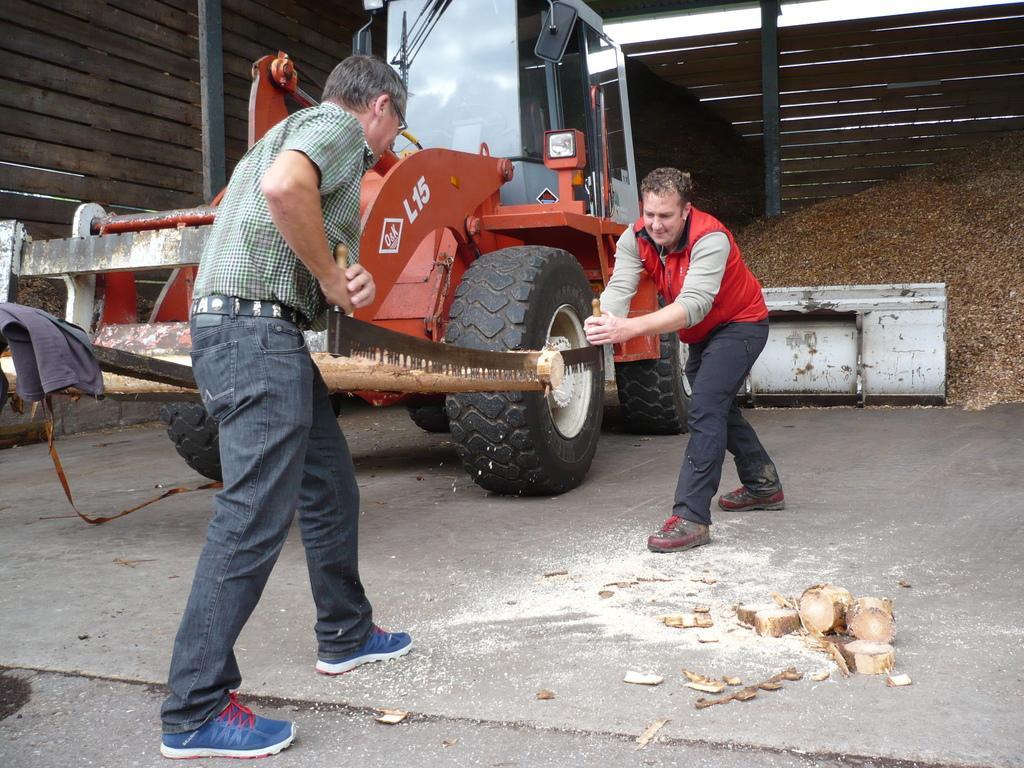Please provide a concise description of this image. In the center of the image we can see two persons are standing and they are holding one object. With that object, they both are cutting the wood. And on the right side, we can see woods. In the background there is a wooden wall, one vehicle and wooden particles. 